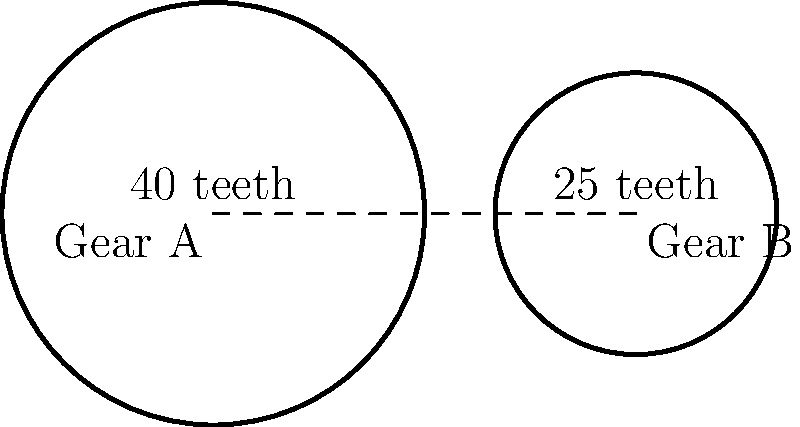In a simple gear train used in a vintage Italian record player, Gear A has 40 teeth and Gear B has 25 teeth. What is the gear ratio of this system, expressed as the ratio of the angular velocity of Gear B to Gear A? To determine the gear ratio, we follow these steps:

1. The gear ratio is defined as the ratio of the angular velocity of the output gear (Gear B) to the input gear (Gear A).

2. In a simple gear train, the gear ratio is inversely proportional to the number of teeth on each gear.

3. We can express this relationship mathematically as:

   $$\frac{\omega_B}{\omega_A} = \frac{N_A}{N_B}$$

   Where:
   $\omega_B$ is the angular velocity of Gear B
   $\omega_A$ is the angular velocity of Gear A
   $N_A$ is the number of teeth on Gear A
   $N_B$ is the number of teeth on Gear B

4. Substituting the given values:

   $$\frac{\omega_B}{\omega_A} = \frac{40}{25}$$

5. Simplifying the fraction:

   $$\frac{\omega_B}{\omega_A} = \frac{8}{5} = 1.6$$

Therefore, the gear ratio of this system is 1.6:1, meaning Gear B rotates 1.6 times for every full rotation of Gear A.
Answer: 1.6:1 